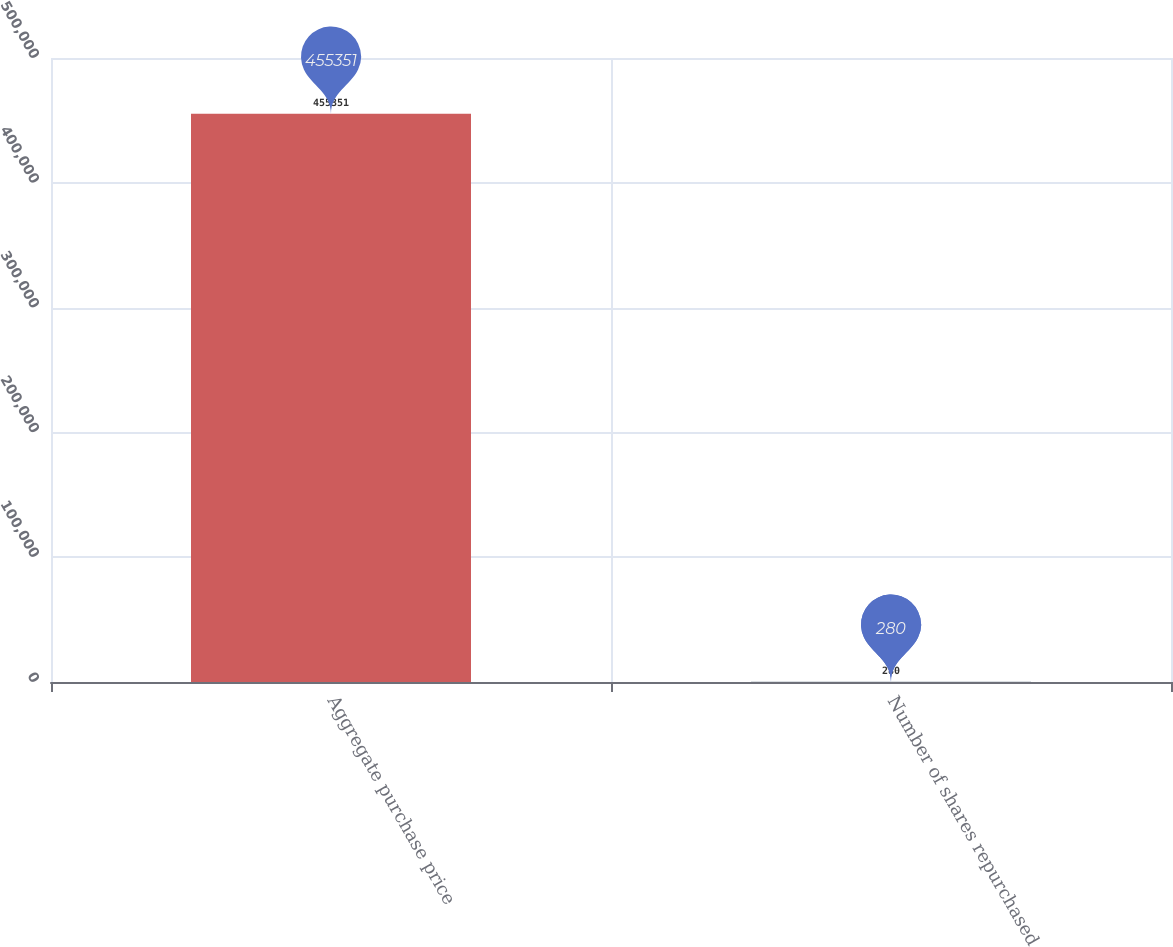Convert chart to OTSL. <chart><loc_0><loc_0><loc_500><loc_500><bar_chart><fcel>Aggregate purchase price<fcel>Number of shares repurchased<nl><fcel>455351<fcel>280<nl></chart> 